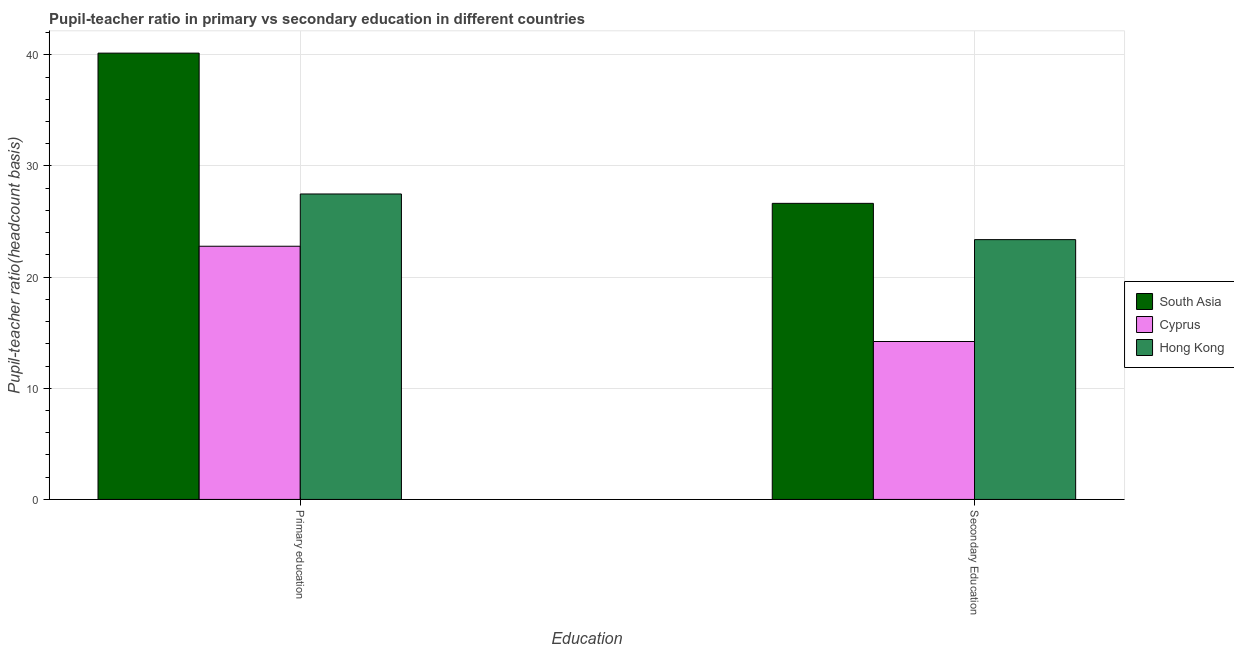How many bars are there on the 2nd tick from the left?
Ensure brevity in your answer.  3. How many bars are there on the 1st tick from the right?
Offer a terse response. 3. What is the label of the 2nd group of bars from the left?
Provide a succinct answer. Secondary Education. What is the pupil-teacher ratio in primary education in Hong Kong?
Keep it short and to the point. 27.48. Across all countries, what is the maximum pupil-teacher ratio in primary education?
Give a very brief answer. 40.15. Across all countries, what is the minimum pupil-teacher ratio in primary education?
Keep it short and to the point. 22.78. In which country was the pupil teacher ratio on secondary education maximum?
Ensure brevity in your answer.  South Asia. In which country was the pupil teacher ratio on secondary education minimum?
Your response must be concise. Cyprus. What is the total pupil-teacher ratio in primary education in the graph?
Make the answer very short. 90.4. What is the difference between the pupil-teacher ratio in primary education in Cyprus and that in South Asia?
Keep it short and to the point. -17.37. What is the difference between the pupil-teacher ratio in primary education in Hong Kong and the pupil teacher ratio on secondary education in South Asia?
Make the answer very short. 0.84. What is the average pupil-teacher ratio in primary education per country?
Give a very brief answer. 30.13. What is the difference between the pupil-teacher ratio in primary education and pupil teacher ratio on secondary education in South Asia?
Provide a short and direct response. 13.51. In how many countries, is the pupil teacher ratio on secondary education greater than 8 ?
Offer a terse response. 3. What is the ratio of the pupil-teacher ratio in primary education in Cyprus to that in Hong Kong?
Offer a very short reply. 0.83. What does the 3rd bar from the left in Primary education represents?
Provide a succinct answer. Hong Kong. What does the 3rd bar from the right in Primary education represents?
Provide a short and direct response. South Asia. How many bars are there?
Keep it short and to the point. 6. What is the difference between two consecutive major ticks on the Y-axis?
Your response must be concise. 10. Are the values on the major ticks of Y-axis written in scientific E-notation?
Make the answer very short. No. Does the graph contain any zero values?
Your answer should be compact. No. Does the graph contain grids?
Your response must be concise. Yes. What is the title of the graph?
Your answer should be very brief. Pupil-teacher ratio in primary vs secondary education in different countries. Does "Central African Republic" appear as one of the legend labels in the graph?
Offer a very short reply. No. What is the label or title of the X-axis?
Ensure brevity in your answer.  Education. What is the label or title of the Y-axis?
Ensure brevity in your answer.  Pupil-teacher ratio(headcount basis). What is the Pupil-teacher ratio(headcount basis) of South Asia in Primary education?
Provide a succinct answer. 40.15. What is the Pupil-teacher ratio(headcount basis) in Cyprus in Primary education?
Your answer should be very brief. 22.78. What is the Pupil-teacher ratio(headcount basis) in Hong Kong in Primary education?
Ensure brevity in your answer.  27.48. What is the Pupil-teacher ratio(headcount basis) of South Asia in Secondary Education?
Your answer should be very brief. 26.63. What is the Pupil-teacher ratio(headcount basis) of Cyprus in Secondary Education?
Offer a terse response. 14.21. What is the Pupil-teacher ratio(headcount basis) in Hong Kong in Secondary Education?
Ensure brevity in your answer.  23.37. Across all Education, what is the maximum Pupil-teacher ratio(headcount basis) in South Asia?
Make the answer very short. 40.15. Across all Education, what is the maximum Pupil-teacher ratio(headcount basis) in Cyprus?
Offer a very short reply. 22.78. Across all Education, what is the maximum Pupil-teacher ratio(headcount basis) of Hong Kong?
Provide a succinct answer. 27.48. Across all Education, what is the minimum Pupil-teacher ratio(headcount basis) of South Asia?
Your response must be concise. 26.63. Across all Education, what is the minimum Pupil-teacher ratio(headcount basis) in Cyprus?
Offer a terse response. 14.21. Across all Education, what is the minimum Pupil-teacher ratio(headcount basis) of Hong Kong?
Your response must be concise. 23.37. What is the total Pupil-teacher ratio(headcount basis) of South Asia in the graph?
Provide a succinct answer. 66.78. What is the total Pupil-teacher ratio(headcount basis) of Cyprus in the graph?
Your answer should be compact. 36.98. What is the total Pupil-teacher ratio(headcount basis) in Hong Kong in the graph?
Provide a succinct answer. 50.85. What is the difference between the Pupil-teacher ratio(headcount basis) in South Asia in Primary education and that in Secondary Education?
Offer a terse response. 13.51. What is the difference between the Pupil-teacher ratio(headcount basis) of Cyprus in Primary education and that in Secondary Education?
Your answer should be compact. 8.57. What is the difference between the Pupil-teacher ratio(headcount basis) in Hong Kong in Primary education and that in Secondary Education?
Offer a very short reply. 4.11. What is the difference between the Pupil-teacher ratio(headcount basis) of South Asia in Primary education and the Pupil-teacher ratio(headcount basis) of Cyprus in Secondary Education?
Ensure brevity in your answer.  25.94. What is the difference between the Pupil-teacher ratio(headcount basis) in South Asia in Primary education and the Pupil-teacher ratio(headcount basis) in Hong Kong in Secondary Education?
Provide a short and direct response. 16.78. What is the difference between the Pupil-teacher ratio(headcount basis) of Cyprus in Primary education and the Pupil-teacher ratio(headcount basis) of Hong Kong in Secondary Education?
Keep it short and to the point. -0.59. What is the average Pupil-teacher ratio(headcount basis) of South Asia per Education?
Your answer should be compact. 33.39. What is the average Pupil-teacher ratio(headcount basis) in Cyprus per Education?
Your answer should be very brief. 18.49. What is the average Pupil-teacher ratio(headcount basis) in Hong Kong per Education?
Provide a short and direct response. 25.42. What is the difference between the Pupil-teacher ratio(headcount basis) of South Asia and Pupil-teacher ratio(headcount basis) of Cyprus in Primary education?
Offer a very short reply. 17.37. What is the difference between the Pupil-teacher ratio(headcount basis) of South Asia and Pupil-teacher ratio(headcount basis) of Hong Kong in Primary education?
Make the answer very short. 12.67. What is the difference between the Pupil-teacher ratio(headcount basis) of Cyprus and Pupil-teacher ratio(headcount basis) of Hong Kong in Primary education?
Your answer should be compact. -4.7. What is the difference between the Pupil-teacher ratio(headcount basis) in South Asia and Pupil-teacher ratio(headcount basis) in Cyprus in Secondary Education?
Offer a very short reply. 12.43. What is the difference between the Pupil-teacher ratio(headcount basis) in South Asia and Pupil-teacher ratio(headcount basis) in Hong Kong in Secondary Education?
Give a very brief answer. 3.26. What is the difference between the Pupil-teacher ratio(headcount basis) in Cyprus and Pupil-teacher ratio(headcount basis) in Hong Kong in Secondary Education?
Give a very brief answer. -9.17. What is the ratio of the Pupil-teacher ratio(headcount basis) in South Asia in Primary education to that in Secondary Education?
Ensure brevity in your answer.  1.51. What is the ratio of the Pupil-teacher ratio(headcount basis) in Cyprus in Primary education to that in Secondary Education?
Keep it short and to the point. 1.6. What is the ratio of the Pupil-teacher ratio(headcount basis) of Hong Kong in Primary education to that in Secondary Education?
Ensure brevity in your answer.  1.18. What is the difference between the highest and the second highest Pupil-teacher ratio(headcount basis) in South Asia?
Give a very brief answer. 13.51. What is the difference between the highest and the second highest Pupil-teacher ratio(headcount basis) of Cyprus?
Your answer should be very brief. 8.57. What is the difference between the highest and the second highest Pupil-teacher ratio(headcount basis) in Hong Kong?
Offer a terse response. 4.11. What is the difference between the highest and the lowest Pupil-teacher ratio(headcount basis) in South Asia?
Provide a succinct answer. 13.51. What is the difference between the highest and the lowest Pupil-teacher ratio(headcount basis) of Cyprus?
Give a very brief answer. 8.57. What is the difference between the highest and the lowest Pupil-teacher ratio(headcount basis) in Hong Kong?
Keep it short and to the point. 4.11. 